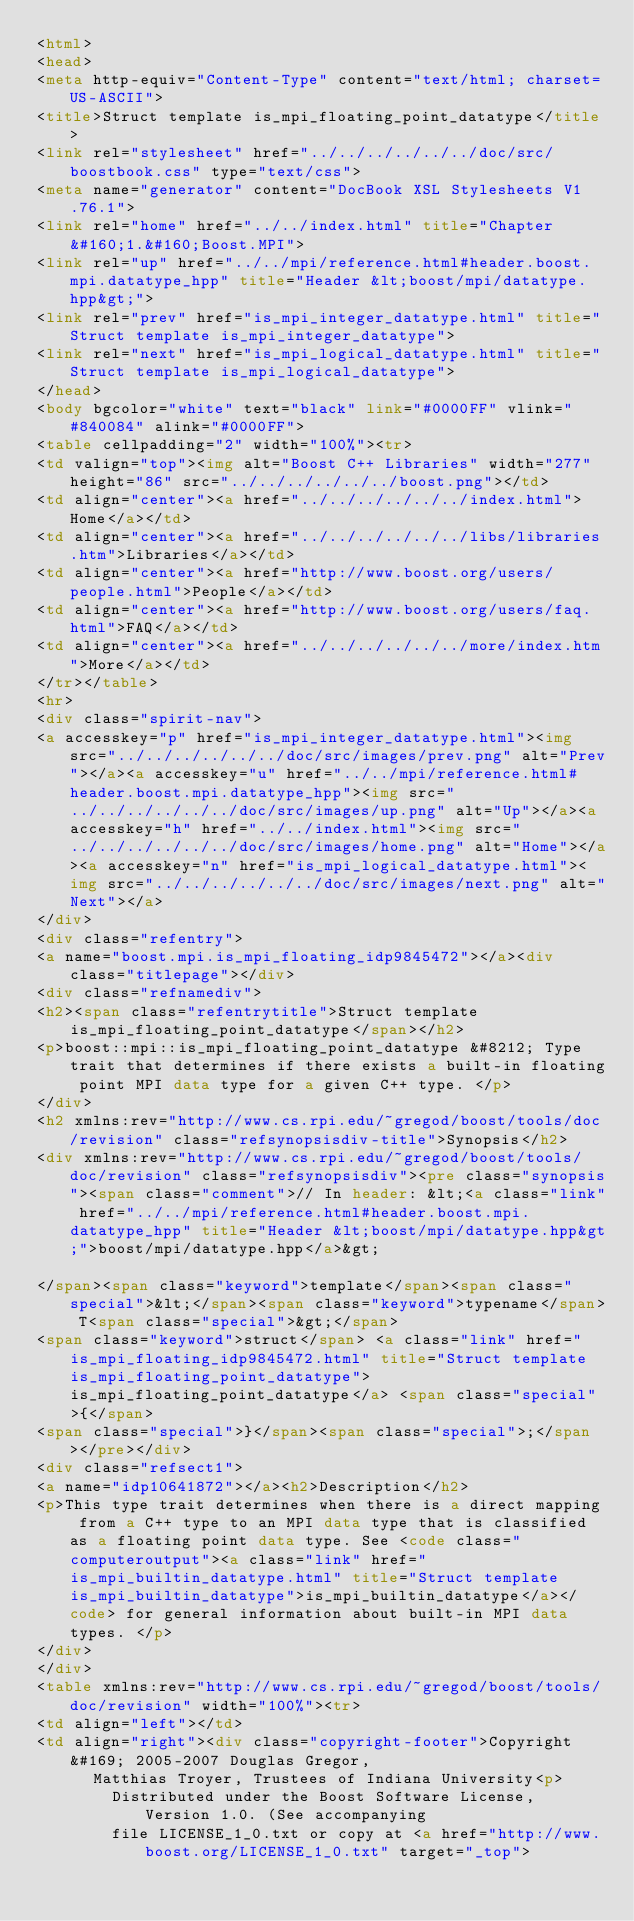Convert code to text. <code><loc_0><loc_0><loc_500><loc_500><_HTML_><html>
<head>
<meta http-equiv="Content-Type" content="text/html; charset=US-ASCII">
<title>Struct template is_mpi_floating_point_datatype</title>
<link rel="stylesheet" href="../../../../../../doc/src/boostbook.css" type="text/css">
<meta name="generator" content="DocBook XSL Stylesheets V1.76.1">
<link rel="home" href="../../index.html" title="Chapter&#160;1.&#160;Boost.MPI">
<link rel="up" href="../../mpi/reference.html#header.boost.mpi.datatype_hpp" title="Header &lt;boost/mpi/datatype.hpp&gt;">
<link rel="prev" href="is_mpi_integer_datatype.html" title="Struct template is_mpi_integer_datatype">
<link rel="next" href="is_mpi_logical_datatype.html" title="Struct template is_mpi_logical_datatype">
</head>
<body bgcolor="white" text="black" link="#0000FF" vlink="#840084" alink="#0000FF">
<table cellpadding="2" width="100%"><tr>
<td valign="top"><img alt="Boost C++ Libraries" width="277" height="86" src="../../../../../../boost.png"></td>
<td align="center"><a href="../../../../../../index.html">Home</a></td>
<td align="center"><a href="../../../../../../libs/libraries.htm">Libraries</a></td>
<td align="center"><a href="http://www.boost.org/users/people.html">People</a></td>
<td align="center"><a href="http://www.boost.org/users/faq.html">FAQ</a></td>
<td align="center"><a href="../../../../../../more/index.htm">More</a></td>
</tr></table>
<hr>
<div class="spirit-nav">
<a accesskey="p" href="is_mpi_integer_datatype.html"><img src="../../../../../../doc/src/images/prev.png" alt="Prev"></a><a accesskey="u" href="../../mpi/reference.html#header.boost.mpi.datatype_hpp"><img src="../../../../../../doc/src/images/up.png" alt="Up"></a><a accesskey="h" href="../../index.html"><img src="../../../../../../doc/src/images/home.png" alt="Home"></a><a accesskey="n" href="is_mpi_logical_datatype.html"><img src="../../../../../../doc/src/images/next.png" alt="Next"></a>
</div>
<div class="refentry">
<a name="boost.mpi.is_mpi_floating_idp9845472"></a><div class="titlepage"></div>
<div class="refnamediv">
<h2><span class="refentrytitle">Struct template is_mpi_floating_point_datatype</span></h2>
<p>boost::mpi::is_mpi_floating_point_datatype &#8212; Type trait that determines if there exists a built-in floating point MPI data type for a given C++ type. </p>
</div>
<h2 xmlns:rev="http://www.cs.rpi.edu/~gregod/boost/tools/doc/revision" class="refsynopsisdiv-title">Synopsis</h2>
<div xmlns:rev="http://www.cs.rpi.edu/~gregod/boost/tools/doc/revision" class="refsynopsisdiv"><pre class="synopsis"><span class="comment">// In header: &lt;<a class="link" href="../../mpi/reference.html#header.boost.mpi.datatype_hpp" title="Header &lt;boost/mpi/datatype.hpp&gt;">boost/mpi/datatype.hpp</a>&gt;

</span><span class="keyword">template</span><span class="special">&lt;</span><span class="keyword">typename</span> T<span class="special">&gt;</span> 
<span class="keyword">struct</span> <a class="link" href="is_mpi_floating_idp9845472.html" title="Struct template is_mpi_floating_point_datatype">is_mpi_floating_point_datatype</a> <span class="special">{</span>
<span class="special">}</span><span class="special">;</span></pre></div>
<div class="refsect1">
<a name="idp10641872"></a><h2>Description</h2>
<p>This type trait determines when there is a direct mapping from a C++ type to an MPI data type that is classified as a floating point data type. See <code class="computeroutput"><a class="link" href="is_mpi_builtin_datatype.html" title="Struct template is_mpi_builtin_datatype">is_mpi_builtin_datatype</a></code> for general information about built-in MPI data types. </p>
</div>
</div>
<table xmlns:rev="http://www.cs.rpi.edu/~gregod/boost/tools/doc/revision" width="100%"><tr>
<td align="left"></td>
<td align="right"><div class="copyright-footer">Copyright &#169; 2005-2007 Douglas Gregor,
      Matthias Troyer, Trustees of Indiana University<p>
        Distributed under the Boost Software License, Version 1.0. (See accompanying
        file LICENSE_1_0.txt or copy at <a href="http://www.boost.org/LICENSE_1_0.txt" target="_top"></code> 